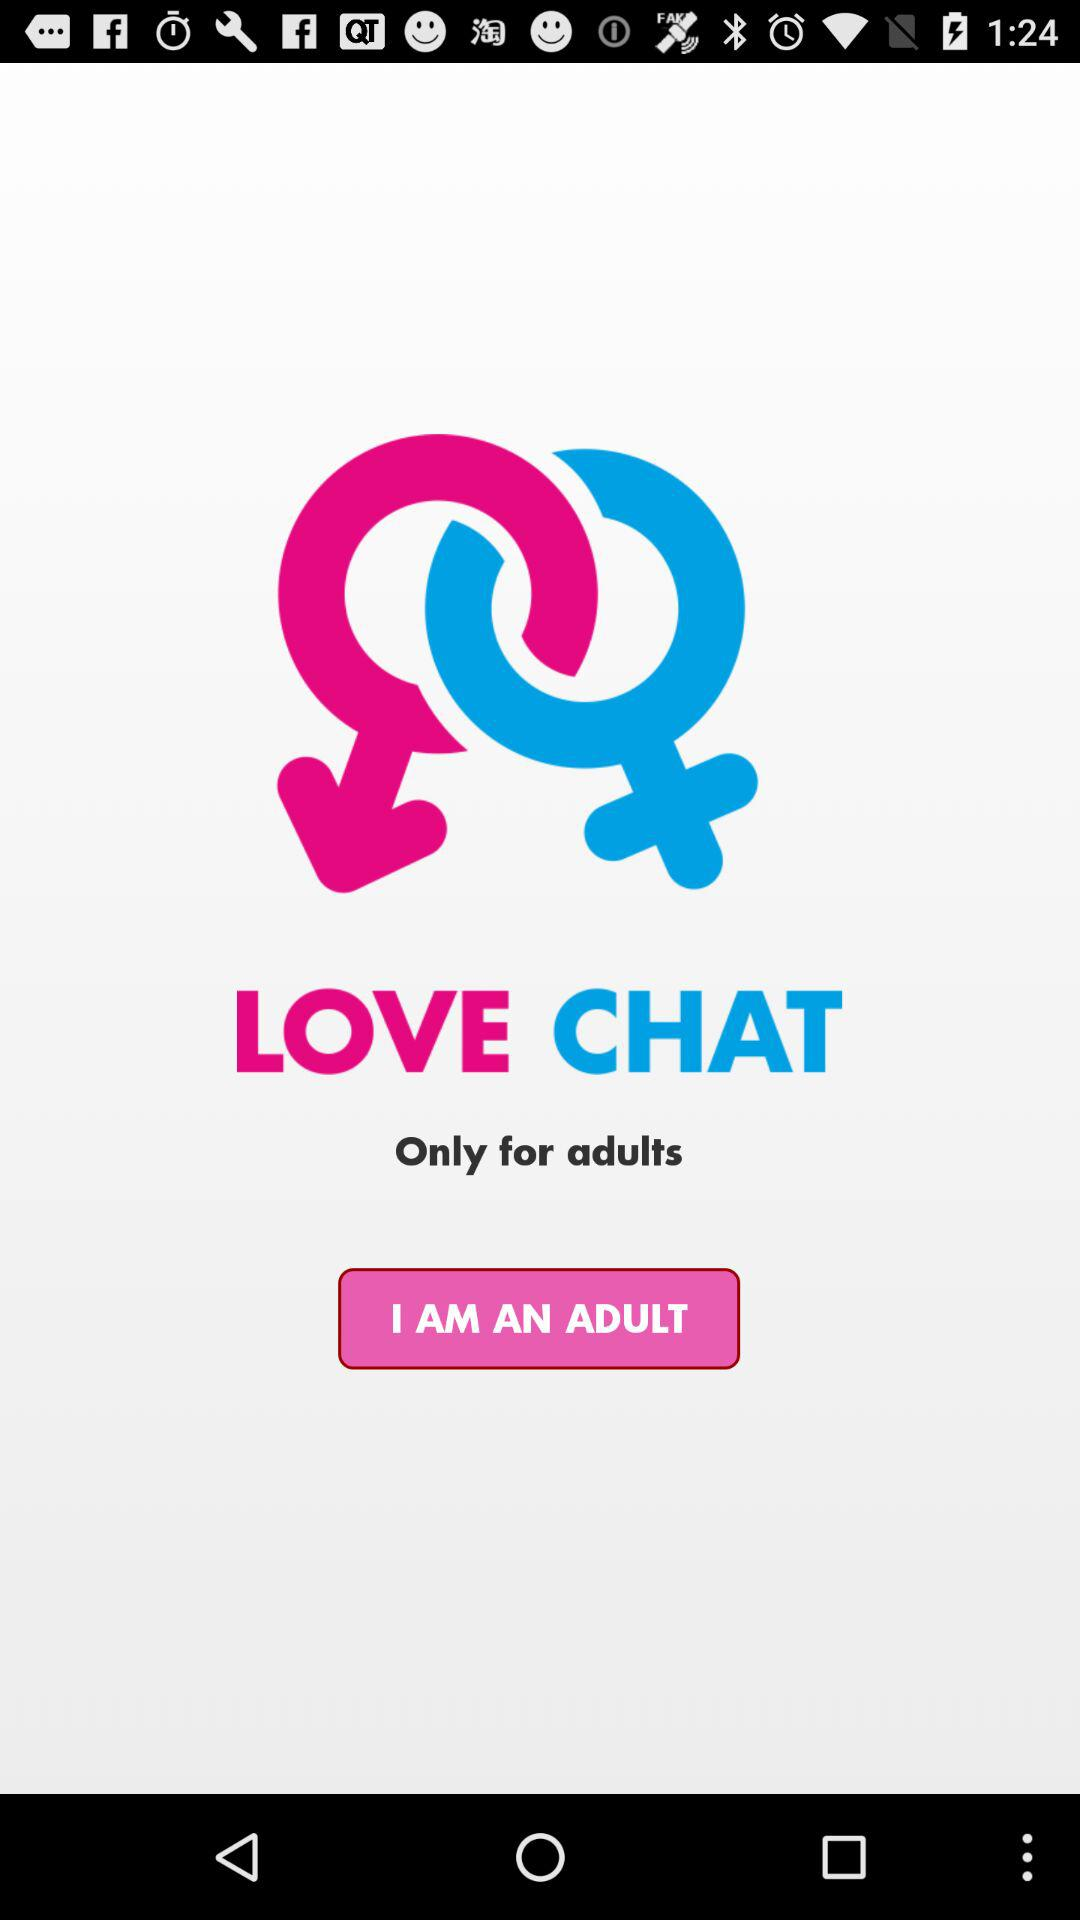What is the application name? The application name is "LOVE CHAT". 